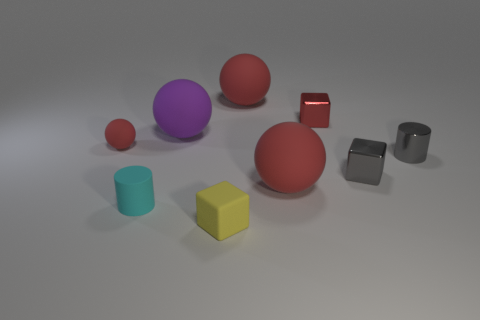There is a tiny cylinder that is made of the same material as the small yellow block; what is its color?
Your answer should be very brief. Cyan. What is the shape of the tiny cyan object?
Your answer should be very brief. Cylinder. How many small shiny things are the same color as the matte cube?
Offer a terse response. 0. The red metallic object that is the same size as the matte block is what shape?
Ensure brevity in your answer.  Cube. Is there a purple object of the same size as the gray metal cube?
Keep it short and to the point. No. There is a ball that is the same size as the cyan rubber object; what is its material?
Your response must be concise. Rubber. There is a red rubber sphere that is in front of the tiny gray object that is left of the shiny cylinder; what is its size?
Provide a succinct answer. Large. Is the size of the red sphere that is left of the yellow cube the same as the large purple sphere?
Your answer should be compact. No. Is the number of tiny red spheres in front of the yellow matte object greater than the number of tiny gray blocks that are in front of the small gray metal cube?
Provide a short and direct response. No. There is a small object that is on the left side of the tiny yellow matte cube and behind the small cyan cylinder; what shape is it?
Give a very brief answer. Sphere. 